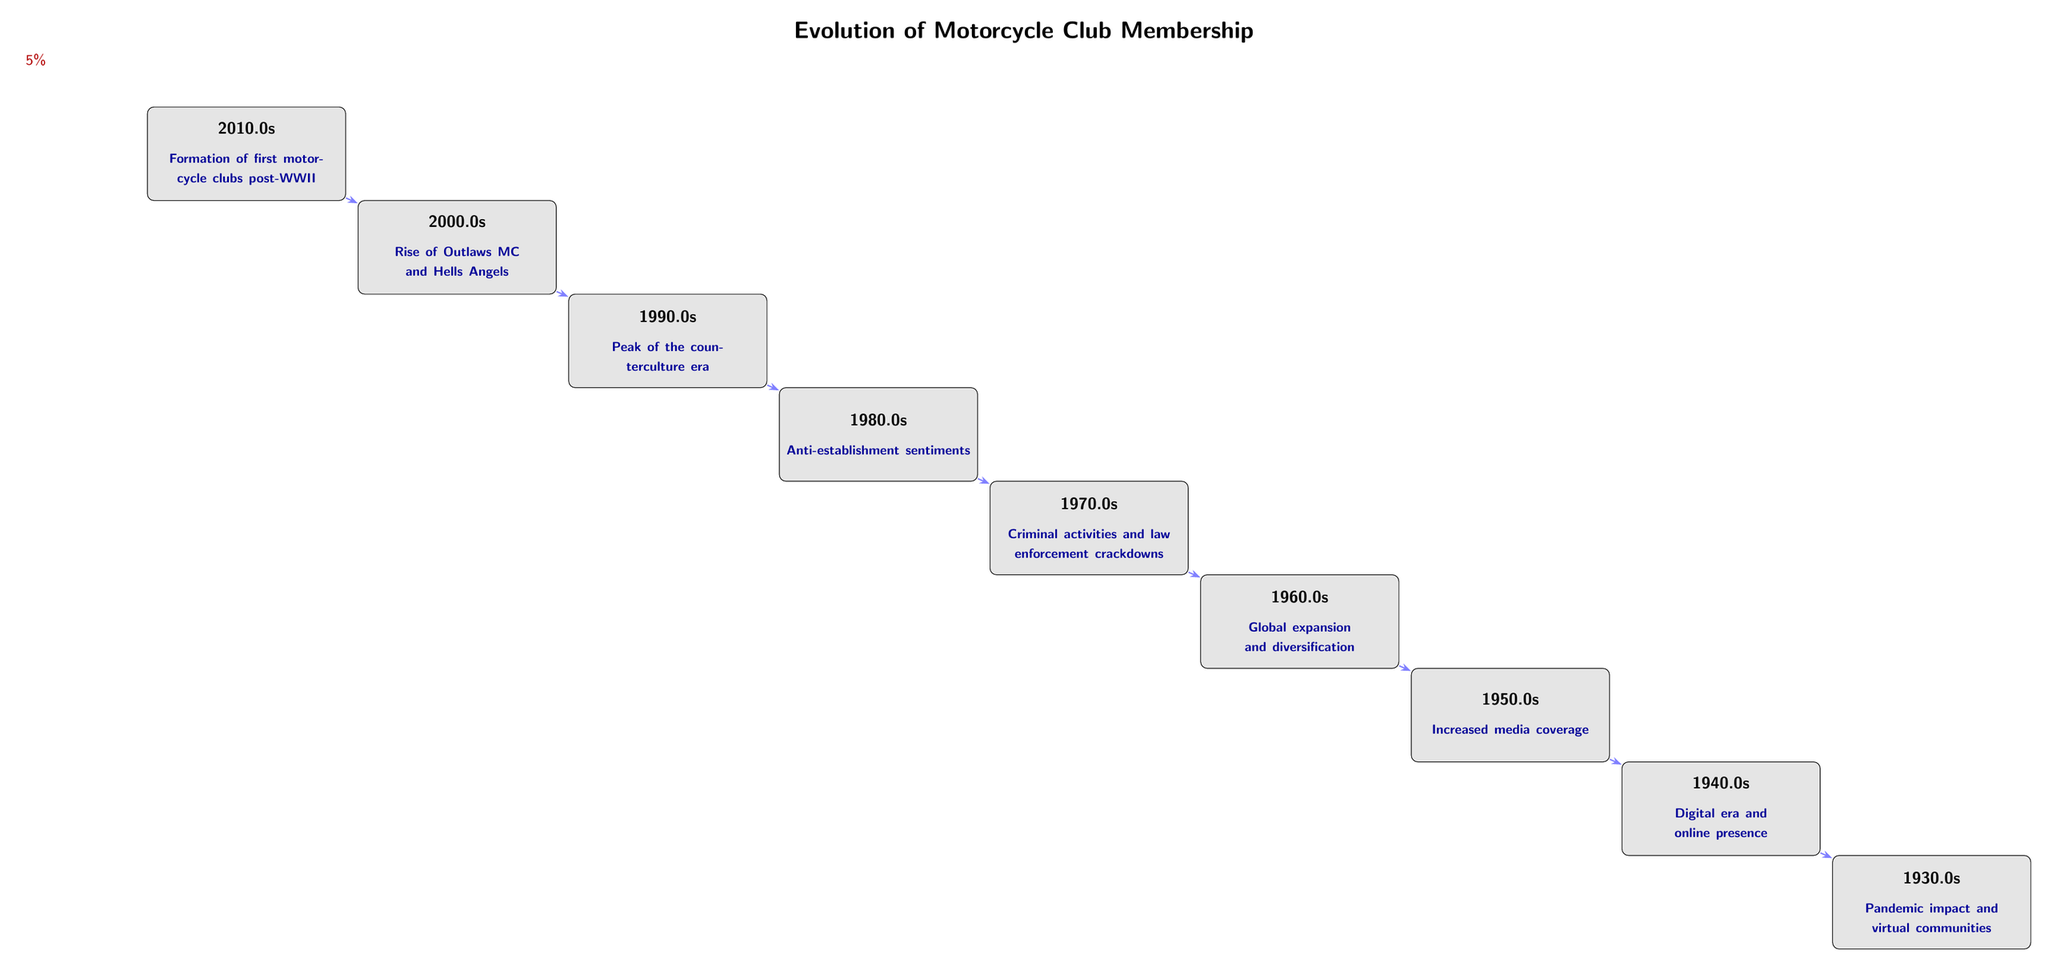What decade marks the formation of the first motorcycle clubs? The diagram indicates that the formation of first motorcycle clubs occurred in 1940s, which is represented by the node labeled "Formation of first motorcycle clubs post-WWII" at the 1940s position.
Answer: 1940s What was the growth rate from the 1960s to the 1970s? To find the growth rate between these two decades, we look at the edges between the nodes representing those decades. The edge from the 1960s to the 1970s indicates a growth rate of 20%.
Answer: 20% How many total nodes are present in the diagram? The total number of nodes representing each decade is counted. The diagram has 9 nodes, each representing a decade of motorcycle club evolution.
Answer: 9 What trend is depicted in the 1990s node? The 1990s node titled "Global expansion and diversification" indicates a significant trend during that decade focused on broader membership beyond local clubs.
Answer: Global expansion and diversification Which decade had the highest growth rate? By analyzing the edges between the nodes, the growth rate from the 1980s to the 1990s, which is stated as 35%, is the highest recorded in the diagram.
Answer: 35% What was the sentiment during the 1970s? The node for the 1970s indicates "Anti-establishment sentiments," which reflects the cultural outlook during that decade regarding motorcycle clubs.
Answer: Anti-establishment sentiments During which decade did criminal activities and law enforcement crackdowns occur? The node for the 1980s is marked with "Criminal activities and law enforcement crackdowns," indicating this was the period focused on those issues.
Answer: 1980s What was the growth rate in the 2010s? The edge connecting the 2010s node presents a growth rate of 5%. This represents the rate of change for motorcycle club membership during that decade.
Answer: 5% Which decade is associated with increased media coverage of motorcycle clubs? The node for the 2000s highlights "Increased media coverage," emphasizing the cultural visibility of motorcycle clubs at that time.
Answer: 2000s 